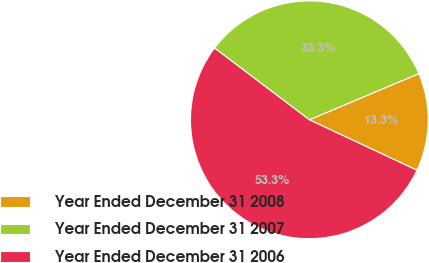Convert chart. <chart><loc_0><loc_0><loc_500><loc_500><pie_chart><fcel>Year Ended December 31 2008<fcel>Year Ended December 31 2007<fcel>Year Ended December 31 2006<nl><fcel>13.33%<fcel>33.33%<fcel>53.33%<nl></chart> 